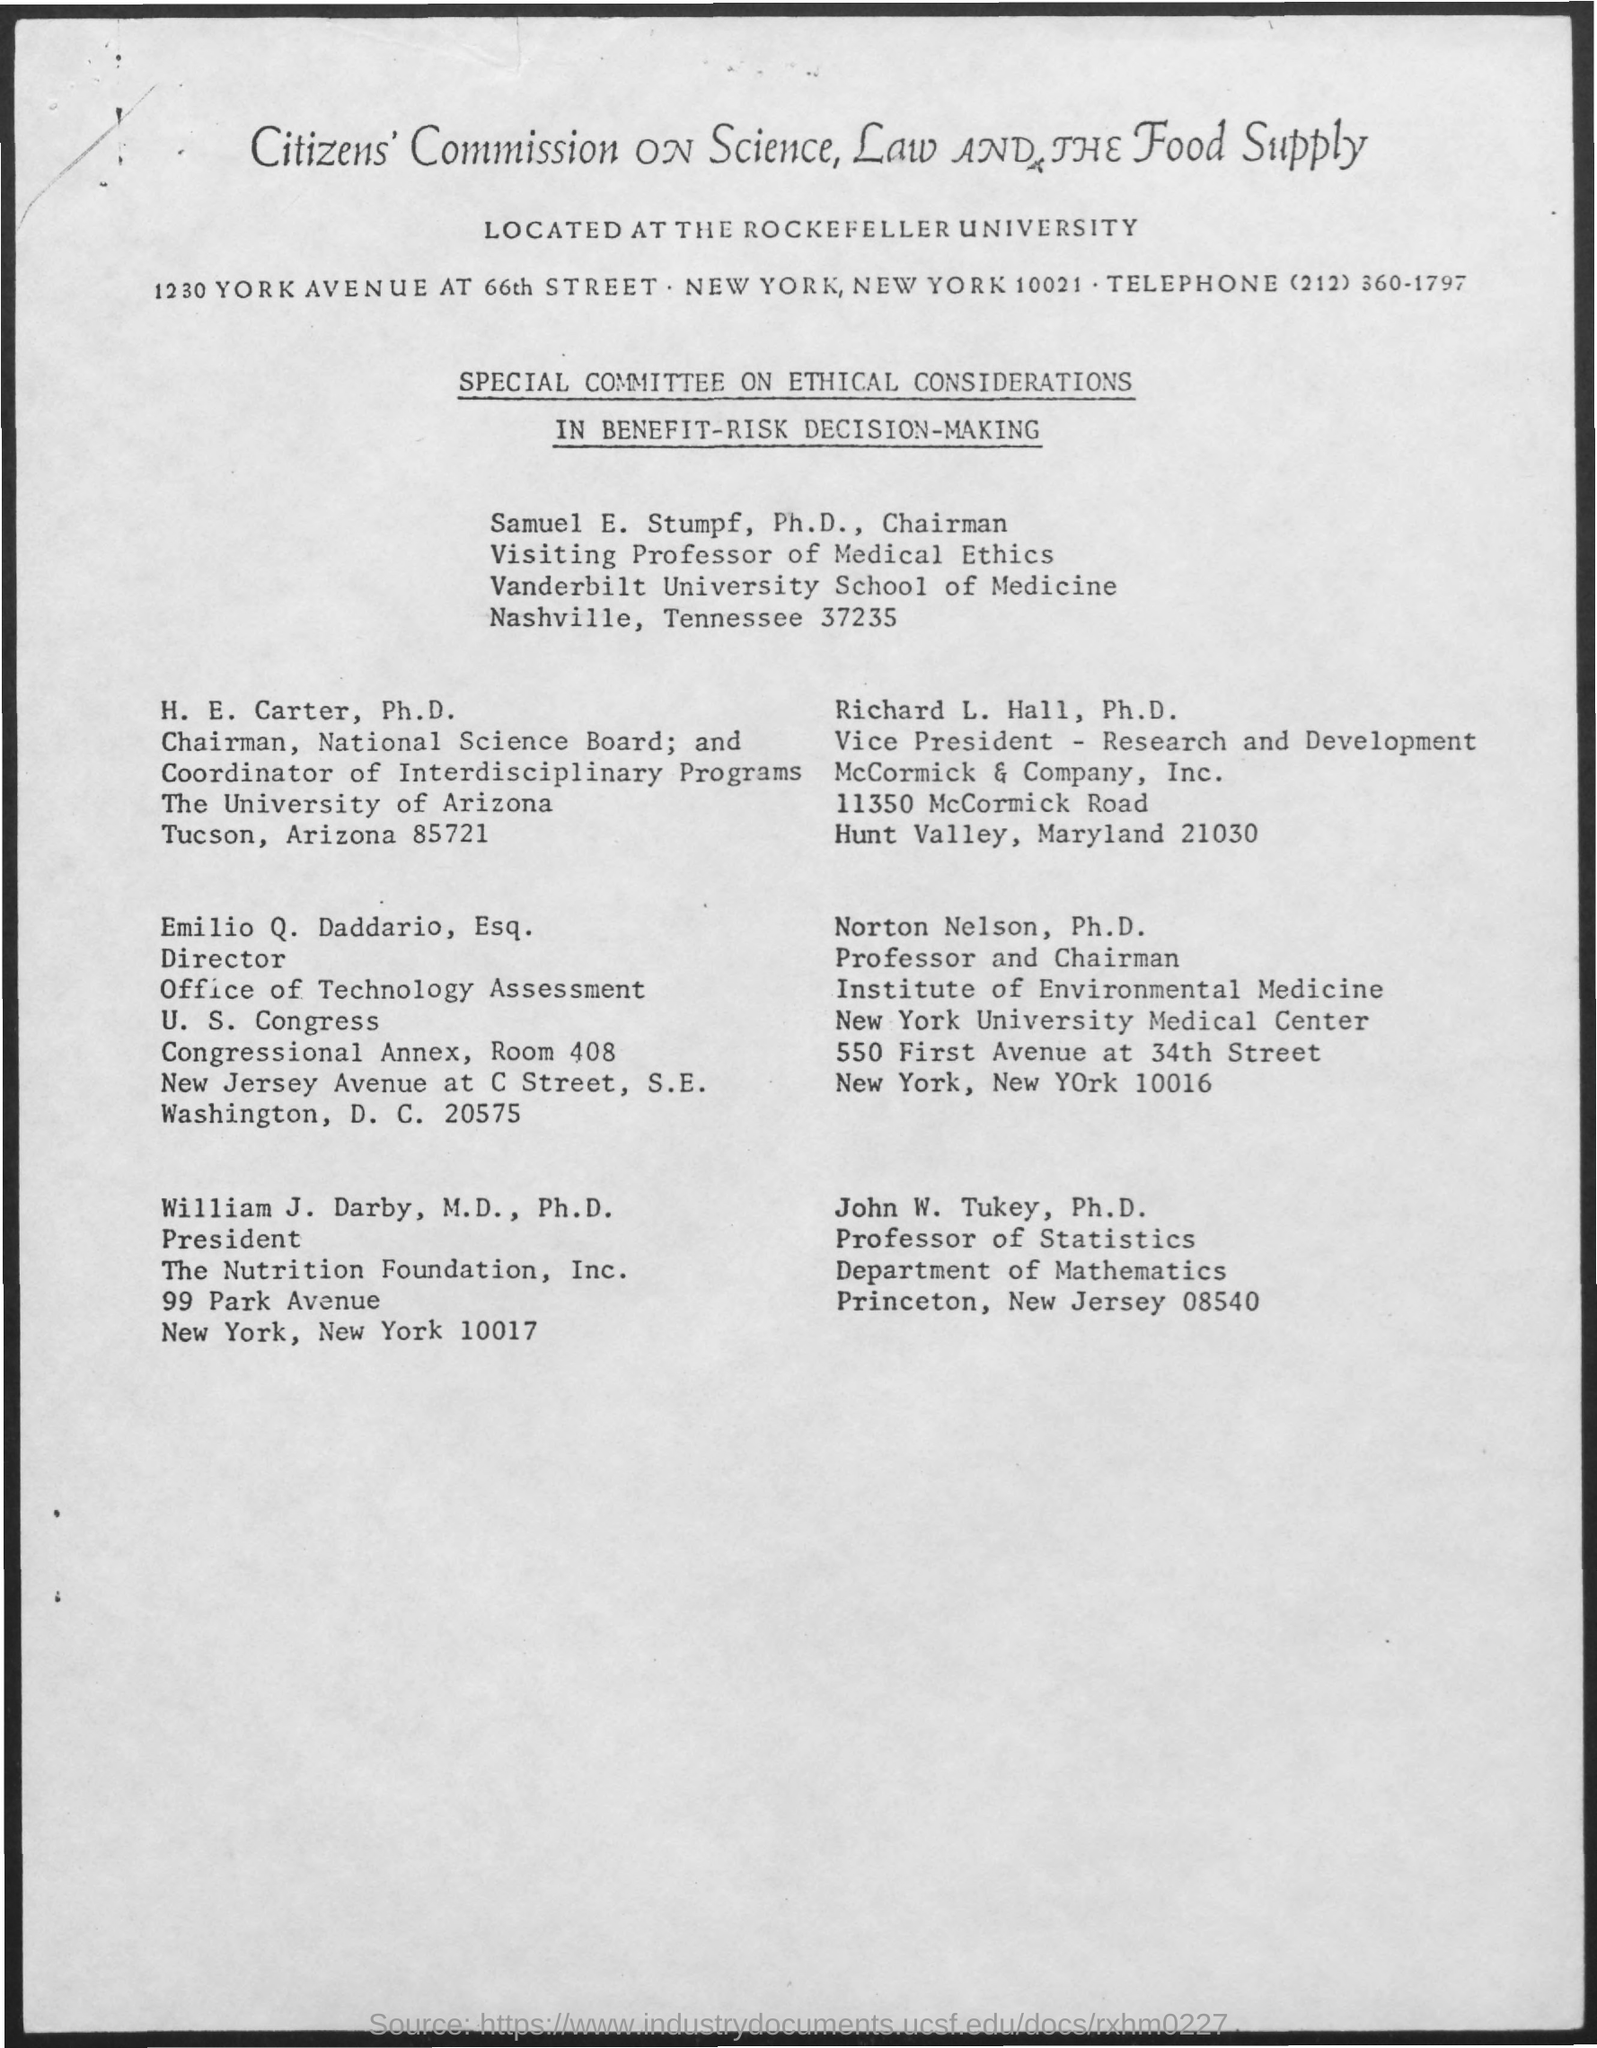Mention a couple of crucial points in this snapshot. John W. Turkey belongs to the Department of Mathematics. William J. Darby has been designated as the president. John W. Turkey is a Professor of Statistics, holding the designation of Professor of Statistics. Norton Nelson is designated as a professor and chairman. The telephone number mentioned in the given page is (212) 360-1797. 